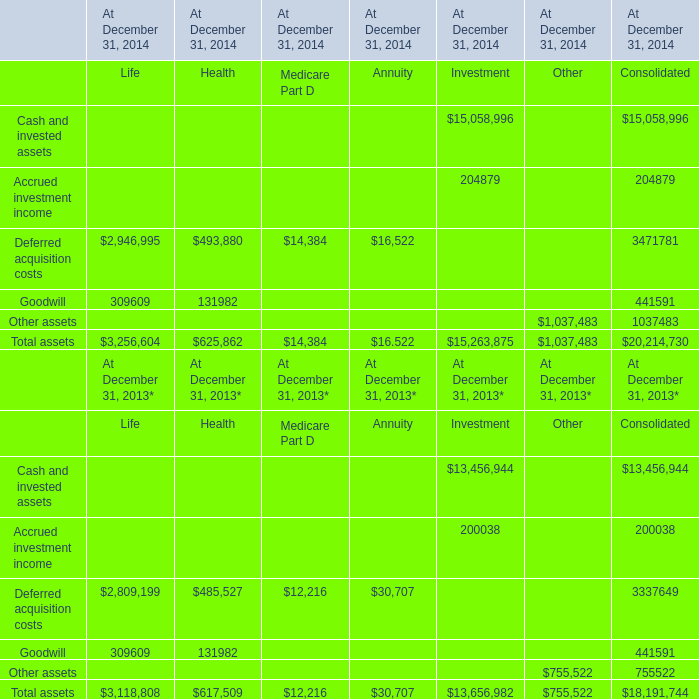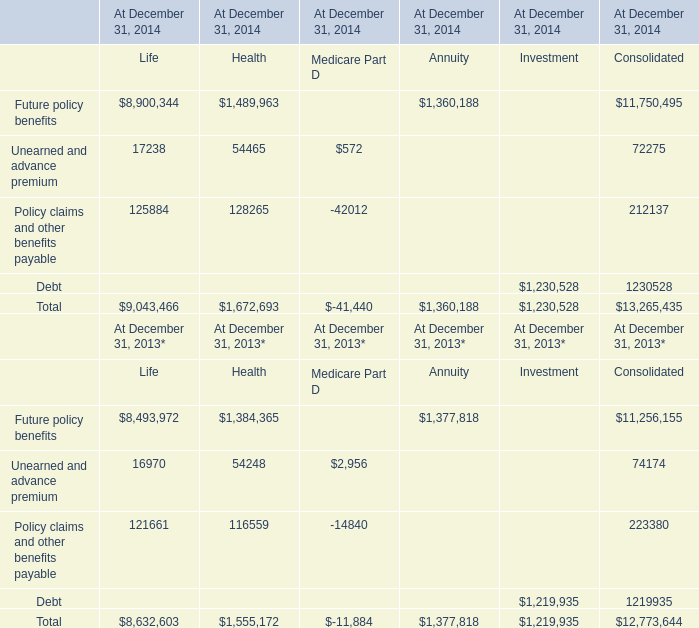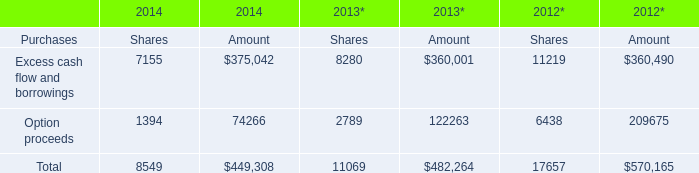What is the total amount of Option proceeds of 2013* Shares, Future policy benefits of At December 31, 2014 Consolidated, and Total of 2012* Amount ? 
Computations: ((2789.0 + 11750495.0) + 570165.0)
Answer: 12323449.0. 